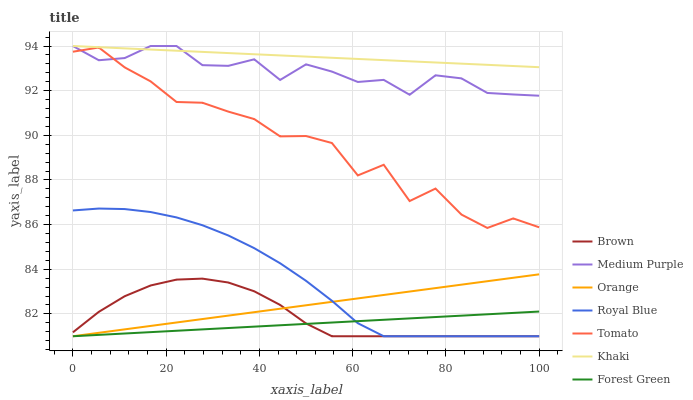Does Forest Green have the minimum area under the curve?
Answer yes or no. Yes. Does Khaki have the maximum area under the curve?
Answer yes or no. Yes. Does Brown have the minimum area under the curve?
Answer yes or no. No. Does Brown have the maximum area under the curve?
Answer yes or no. No. Is Khaki the smoothest?
Answer yes or no. Yes. Is Tomato the roughest?
Answer yes or no. Yes. Is Brown the smoothest?
Answer yes or no. No. Is Brown the roughest?
Answer yes or no. No. Does Brown have the lowest value?
Answer yes or no. Yes. Does Khaki have the lowest value?
Answer yes or no. No. Does Medium Purple have the highest value?
Answer yes or no. Yes. Does Brown have the highest value?
Answer yes or no. No. Is Brown less than Tomato?
Answer yes or no. Yes. Is Tomato greater than Royal Blue?
Answer yes or no. Yes. Does Medium Purple intersect Khaki?
Answer yes or no. Yes. Is Medium Purple less than Khaki?
Answer yes or no. No. Is Medium Purple greater than Khaki?
Answer yes or no. No. Does Brown intersect Tomato?
Answer yes or no. No. 